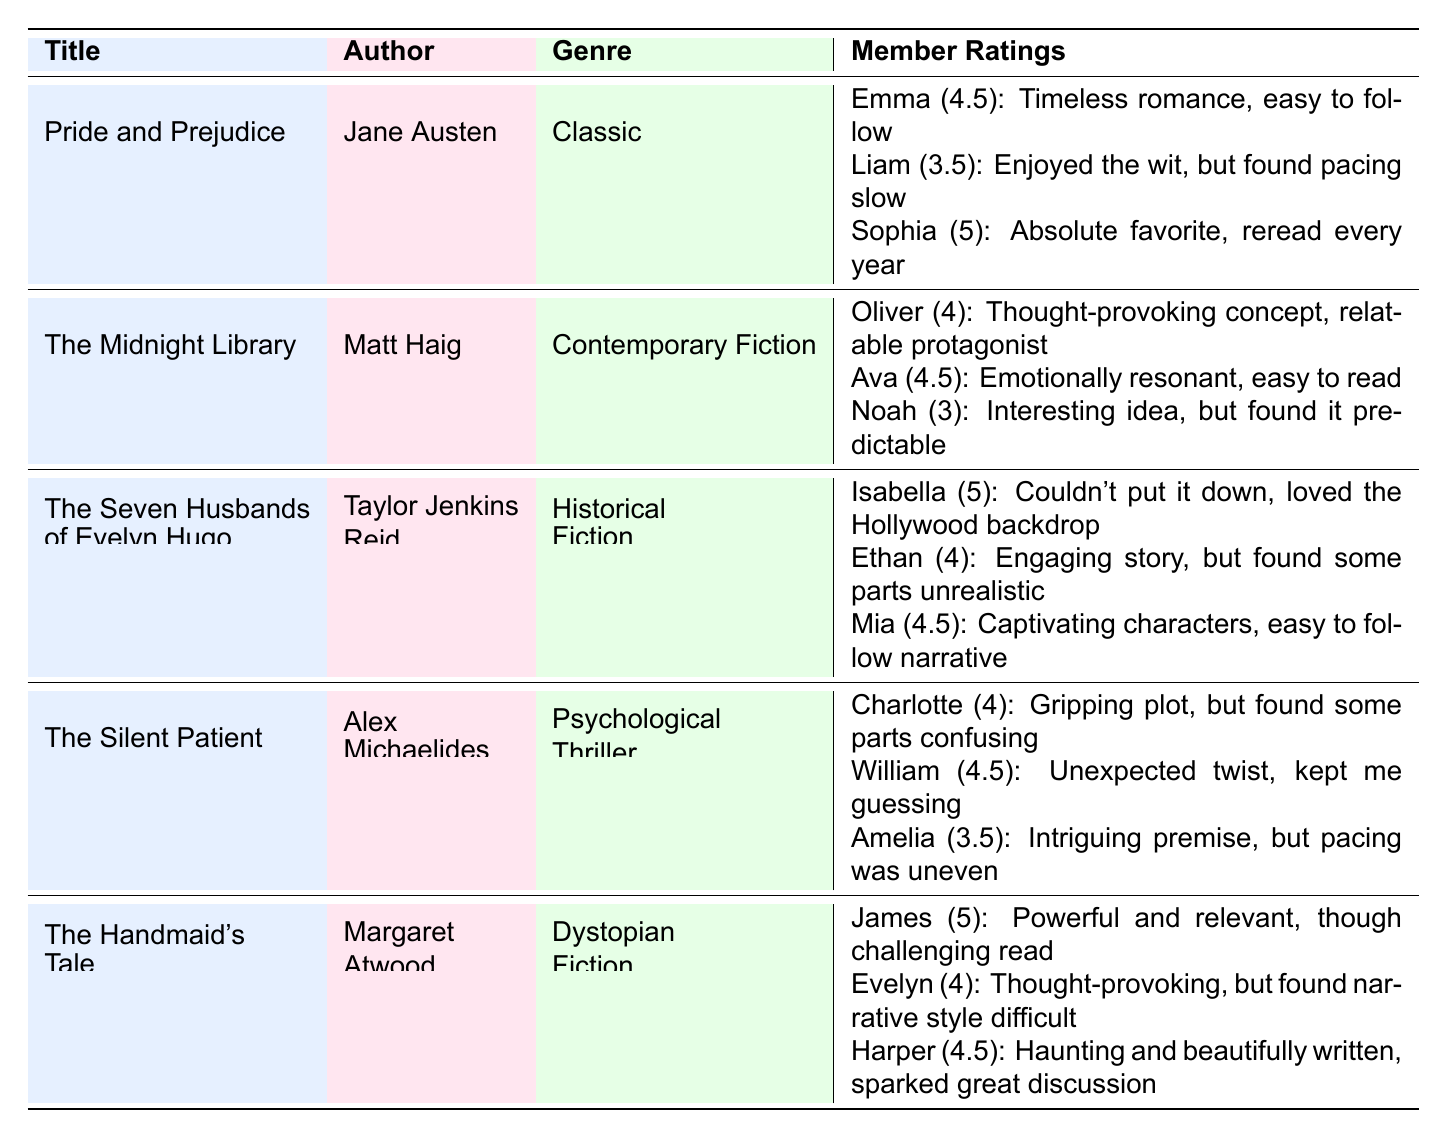What genre does "The Silent Patient" belong to? The table lists "The Silent Patient" under the "Genre" column, which shows it as a "Psychological Thriller."
Answer: Psychological Thriller Who rated "The Handmaid's Tale" the highest, and what was their rating? By reviewing the member ratings for "The Handmaid's Tale," James rated it with a score of 5, which is the highest rating listed.
Answer: James, 5 What is the average rating for "The Midnight Library"? The ratings for "The Midnight Library" are 4, 4.5, and 3. Adding these gives 11, and dividing by 3 (the number of ratings) results in an average of 3.67.
Answer: 3.67 Which member rated "The Seven Husbands of Evelyn Hugo" with a comment about finding some parts unrealistic? Checking the member ratings for "The Seven Husbands of Evelyn Hugo," Ethan gave a rating of 4 and commented on finding some parts unrealistic.
Answer: Ethan Do more members rate "The Handmaid's Tale" high (4 or above) compared to "The Silent Patient"? For "The Handmaid's Tale," three ratings are 5, 4, and 4.5, all above 4. For "The Silent Patient," two ratings are at or above 4 (4, 4.5) out of three. Thus, "The Handmaid's Tale" has more high ratings.
Answer: Yes What percentage of the members rated "Pride and Prejudice" 4 or higher? Of the three ratings for "Pride and Prejudice" (4.5, 3.5, 5), two ratings (4.5 and 5) are 4 or above. (2 out of 3) The percentage is (2/3)*100 = 66.67%.
Answer: 66.67% How many ratings did "The Handmaid's Tale" receive? The number of individual member ratings for "The Handmaid's Tale" listed in the table is three.
Answer: 3 What is the highest rating received by members for "The Seven Husbands of Evelyn Hugo"? The ratings for "The Seven Husbands of Evelyn Hugo" include 5, 4, and 4.5. The highest value among these is 5.
Answer: 5 Which book had the lowest member rating, and what was that rating? Looking through all the ratings, "The Midnight Library" received the lowest rating of 3 by Noah.
Answer: The Midnight Library, 3 Are there any members who rated both "The Silent Patient" and "The Handmaid's Tale"? Analyzing the members, none of the members appear in both books' ratings lists, so there are no overlapping ratings.
Answer: No 